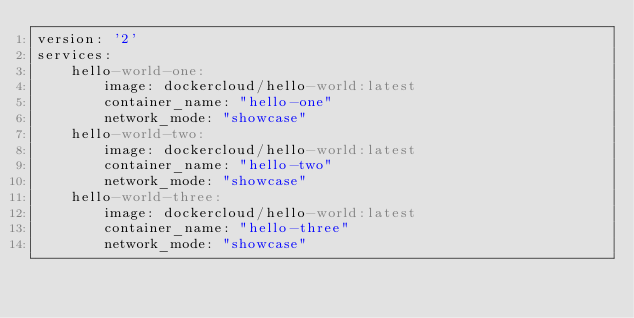<code> <loc_0><loc_0><loc_500><loc_500><_YAML_>version: '2'
services:
    hello-world-one:
        image: dockercloud/hello-world:latest
        container_name: "hello-one"
        network_mode: "showcase"
    hello-world-two:
        image: dockercloud/hello-world:latest
        container_name: "hello-two"
        network_mode: "showcase"
    hello-world-three:
        image: dockercloud/hello-world:latest
        container_name: "hello-three"
        network_mode: "showcase"
</code> 